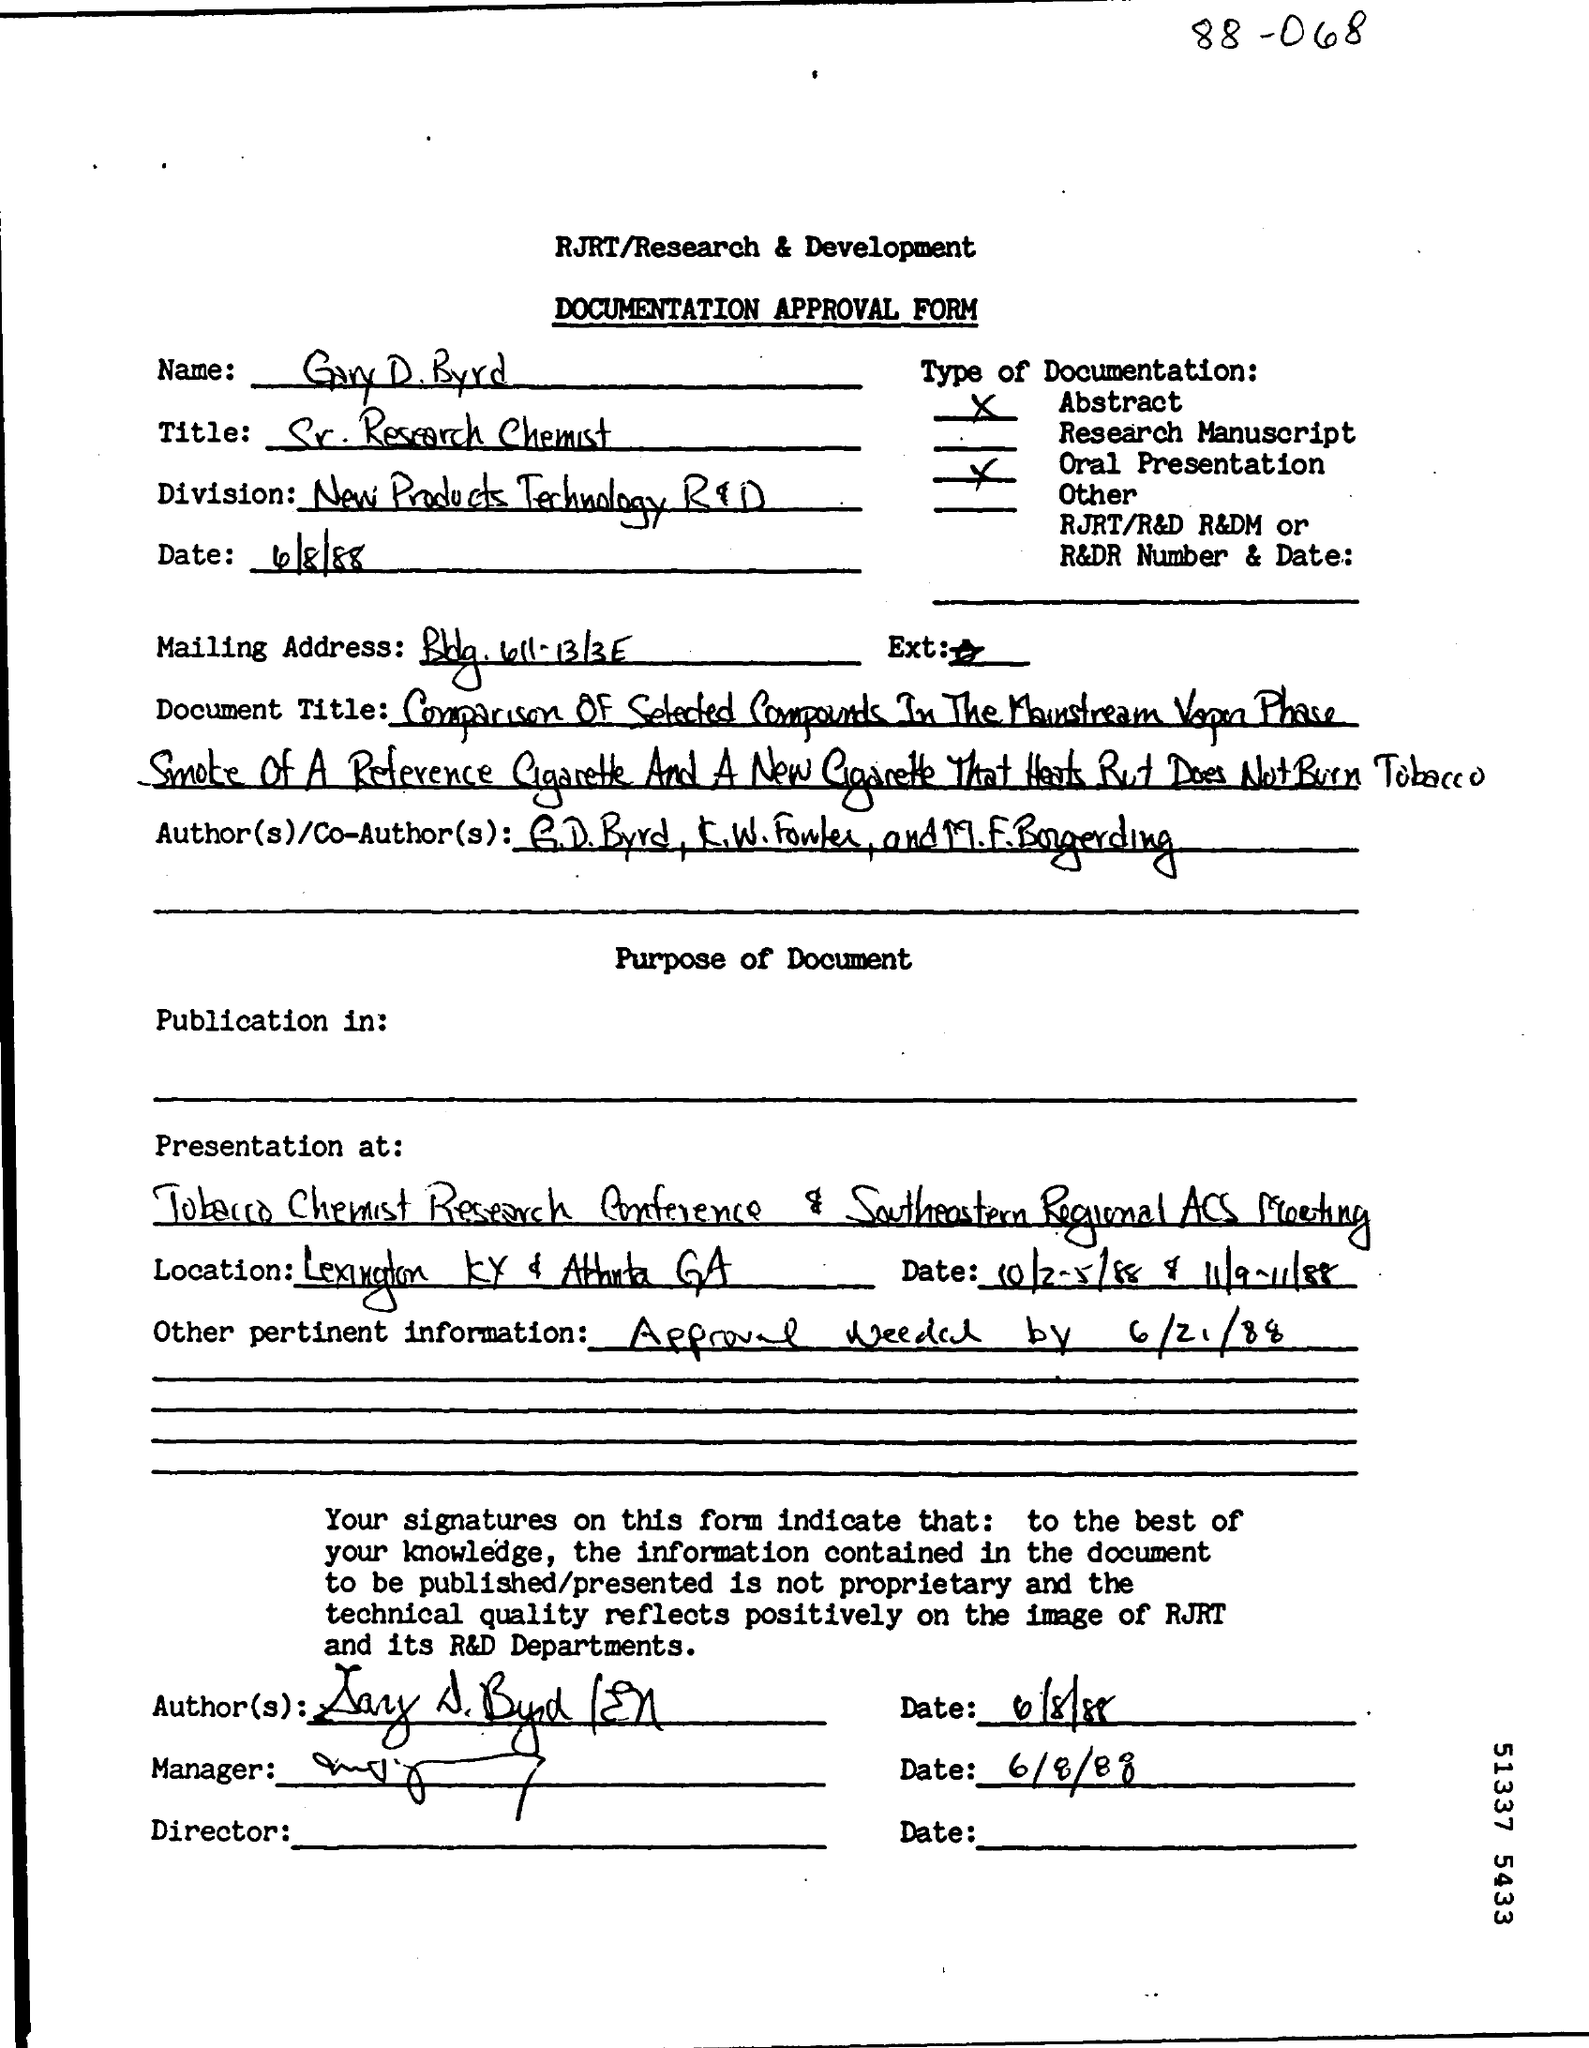Indicate a few pertinent items in this graphic. The division mentioned in the approval form is named "New Products Technology R&D. The date mentioned in the approval form is April 8, 1988. 